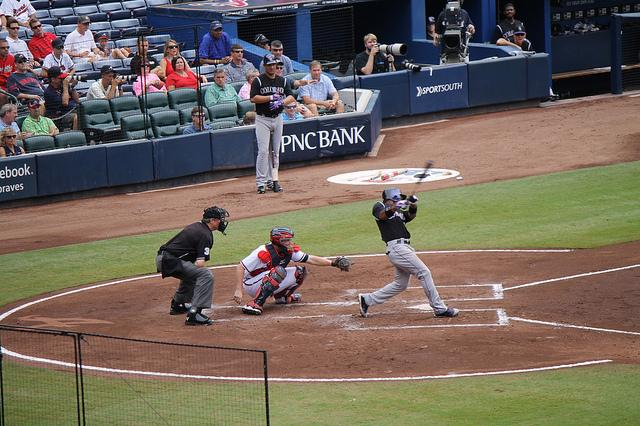Who is an all-time legend for one of these teams?

Choices:
A) michael jordan
B) leroy garrett
C) todd helton
D) tom brady todd helton 